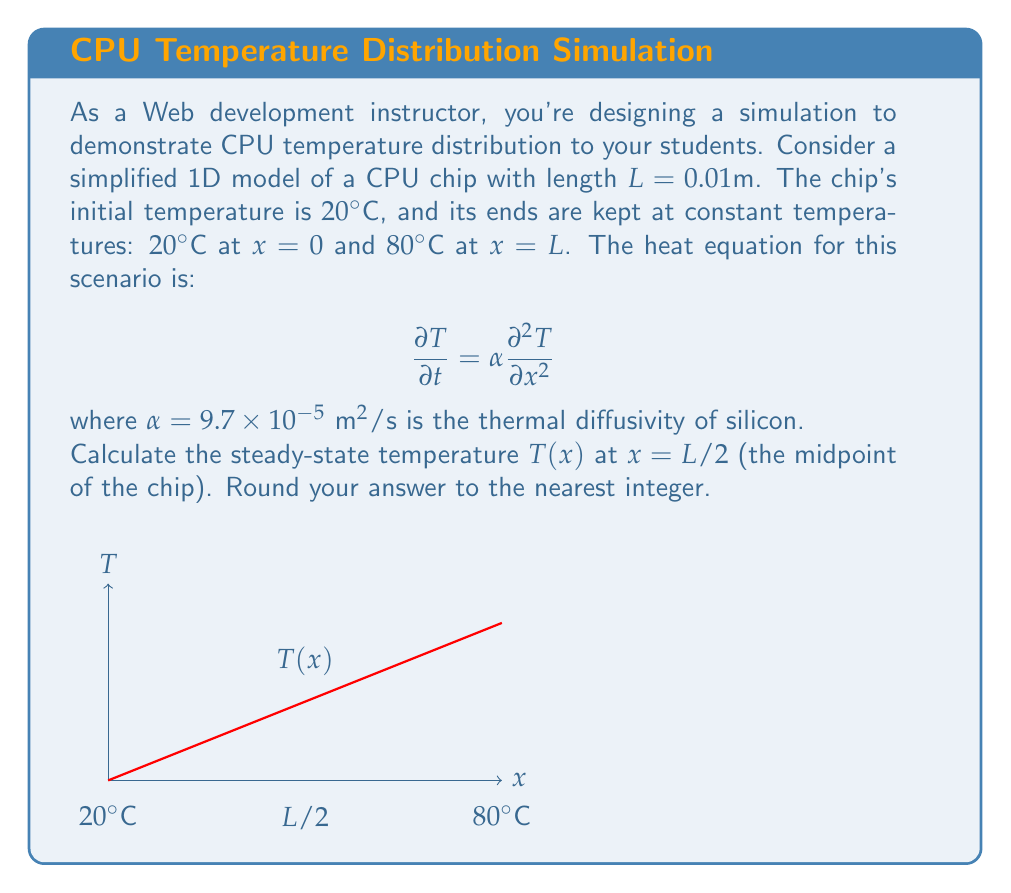Can you answer this question? To solve this problem, we'll follow these steps:

1) The steady-state heat equation is obtained by setting $\frac{\partial T}{\partial t} = 0$:

   $$0 = \alpha \frac{d^2 T}{dx^2}$$

2) Integrating twice:

   $$\frac{dT}{dx} = C_1$$
   $$T(x) = C_1x + C_2$$

3) Apply boundary conditions:
   At x = 0, T = 20°C
   At x = L, T = 80°C

   $$20 = C_2$$
   $$80 = C_1L + 20$$

4) Solve for $C_1$:

   $$C_1 = \frac{80 - 20}{L} = \frac{60}{0.01} = 6000$$

5) The steady-state temperature distribution is:

   $$T(x) = 6000x + 20$$

6) At x = L/2 = 0.005m:

   $$T(0.005) = 6000(0.005) + 20 = 30 + 20 = 50°C$$

7) Rounding to the nearest integer: 50°C
Answer: 50°C 